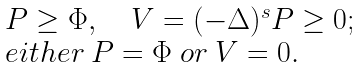<formula> <loc_0><loc_0><loc_500><loc_500>\begin{array} { l } P \geq \Phi , \quad V = ( - \Delta ) ^ { s } P \geq 0 ; \\ e i t h e r \ P = \Phi \ o r \ V = 0 . \end{array}</formula> 